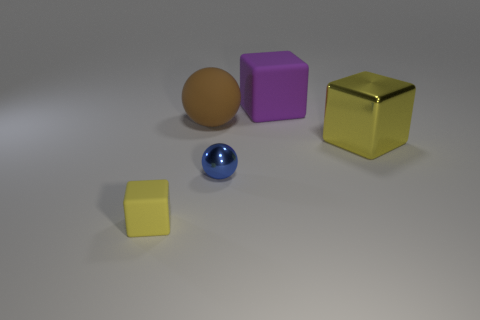Is the number of big brown things to the right of the yellow rubber object greater than the number of small balls behind the big shiny block?
Your answer should be compact. Yes. There is a thing to the right of the rubber cube that is right of the ball behind the metal sphere; what is it made of?
Your answer should be compact. Metal. There is a large object that is the same material as the purple cube; what shape is it?
Make the answer very short. Sphere. Is there a yellow block that is left of the metal object right of the large purple cube?
Offer a very short reply. Yes. What is the size of the brown rubber ball?
Keep it short and to the point. Large. What number of things are matte cubes or big brown objects?
Offer a very short reply. 3. Do the yellow object that is right of the big brown ball and the thing that is on the left side of the large brown thing have the same material?
Make the answer very short. No. There is a thing that is made of the same material as the small blue sphere; what color is it?
Offer a terse response. Yellow. How many yellow rubber cubes have the same size as the purple rubber thing?
Offer a very short reply. 0. What number of other objects are the same color as the big shiny thing?
Offer a very short reply. 1. 